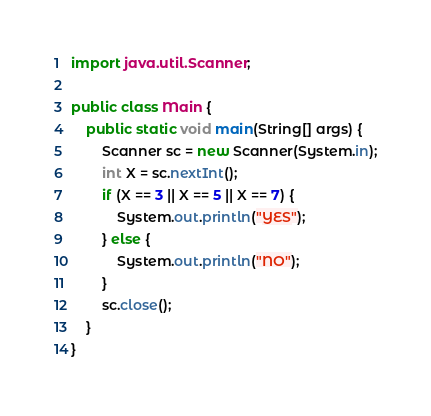<code> <loc_0><loc_0><loc_500><loc_500><_Java_>import java.util.Scanner;

public class Main {
	public static void main(String[] args) {
		Scanner sc = new Scanner(System.in);
		int X = sc.nextInt();
		if (X == 3 || X == 5 || X == 7) {
			System.out.println("YES");
		} else {
			System.out.println("NO");
		}
		sc.close();
	}
}
</code> 